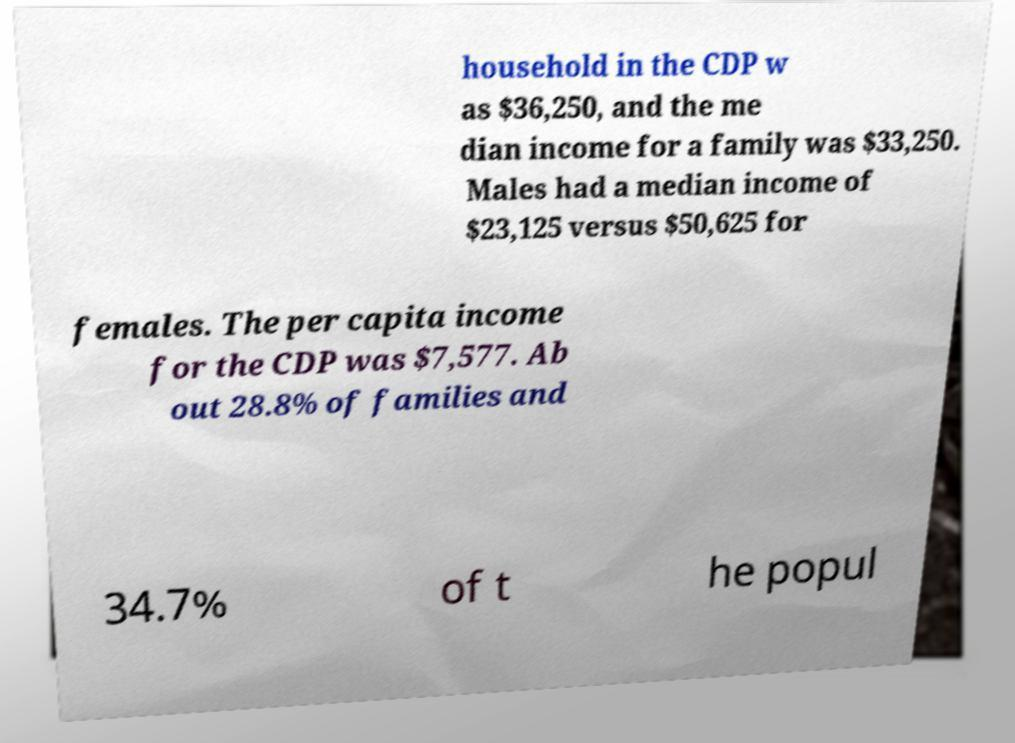For documentation purposes, I need the text within this image transcribed. Could you provide that? household in the CDP w as $36,250, and the me dian income for a family was $33,250. Males had a median income of $23,125 versus $50,625 for females. The per capita income for the CDP was $7,577. Ab out 28.8% of families and 34.7% of t he popul 